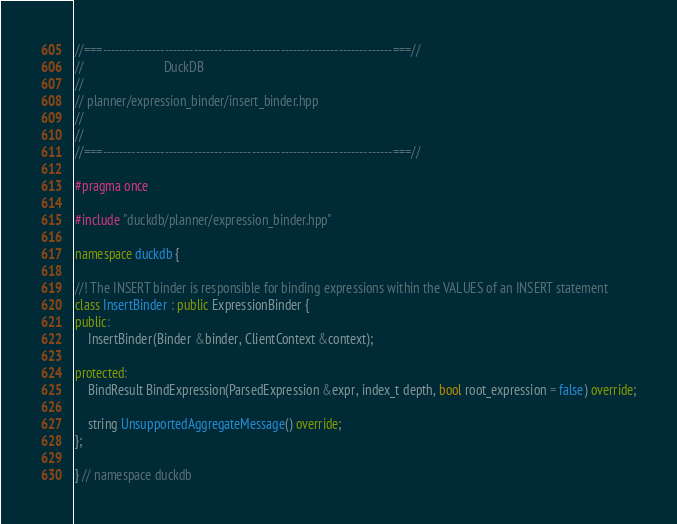Convert code to text. <code><loc_0><loc_0><loc_500><loc_500><_C++_>//===----------------------------------------------------------------------===//
//                         DuckDB
//
// planner/expression_binder/insert_binder.hpp
//
//
//===----------------------------------------------------------------------===//

#pragma once

#include "duckdb/planner/expression_binder.hpp"

namespace duckdb {

//! The INSERT binder is responsible for binding expressions within the VALUES of an INSERT statement
class InsertBinder : public ExpressionBinder {
public:
	InsertBinder(Binder &binder, ClientContext &context);

protected:
	BindResult BindExpression(ParsedExpression &expr, index_t depth, bool root_expression = false) override;

	string UnsupportedAggregateMessage() override;
};

} // namespace duckdb
</code> 